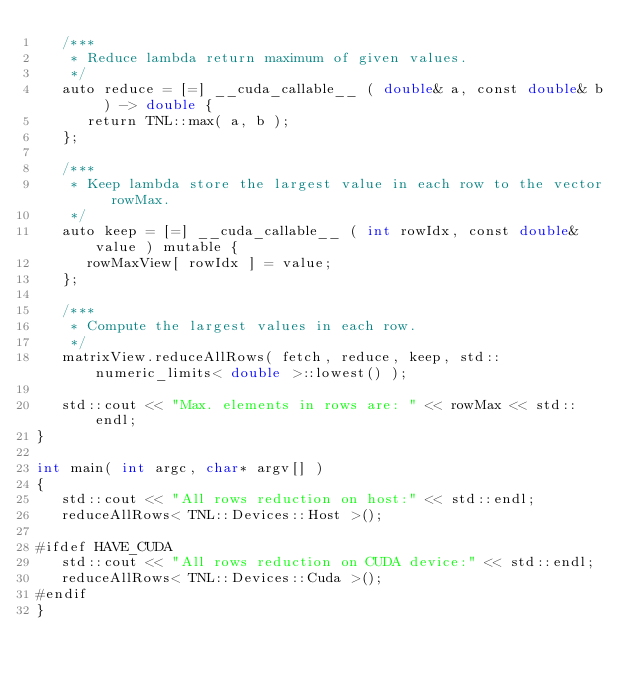Convert code to text. <code><loc_0><loc_0><loc_500><loc_500><_Cuda_>   /***
    * Reduce lambda return maximum of given values.
    */
   auto reduce = [=] __cuda_callable__ ( double& a, const double& b ) -> double {
      return TNL::max( a, b );
   };

   /***
    * Keep lambda store the largest value in each row to the vector rowMax.
    */
   auto keep = [=] __cuda_callable__ ( int rowIdx, const double& value ) mutable {
      rowMaxView[ rowIdx ] = value;
   };

   /***
    * Compute the largest values in each row.
    */
   matrixView.reduceAllRows( fetch, reduce, keep, std::numeric_limits< double >::lowest() );

   std::cout << "Max. elements in rows are: " << rowMax << std::endl;
}

int main( int argc, char* argv[] )
{
   std::cout << "All rows reduction on host:" << std::endl;
   reduceAllRows< TNL::Devices::Host >();

#ifdef HAVE_CUDA
   std::cout << "All rows reduction on CUDA device:" << std::endl;
   reduceAllRows< TNL::Devices::Cuda >();
#endif
}
</code> 